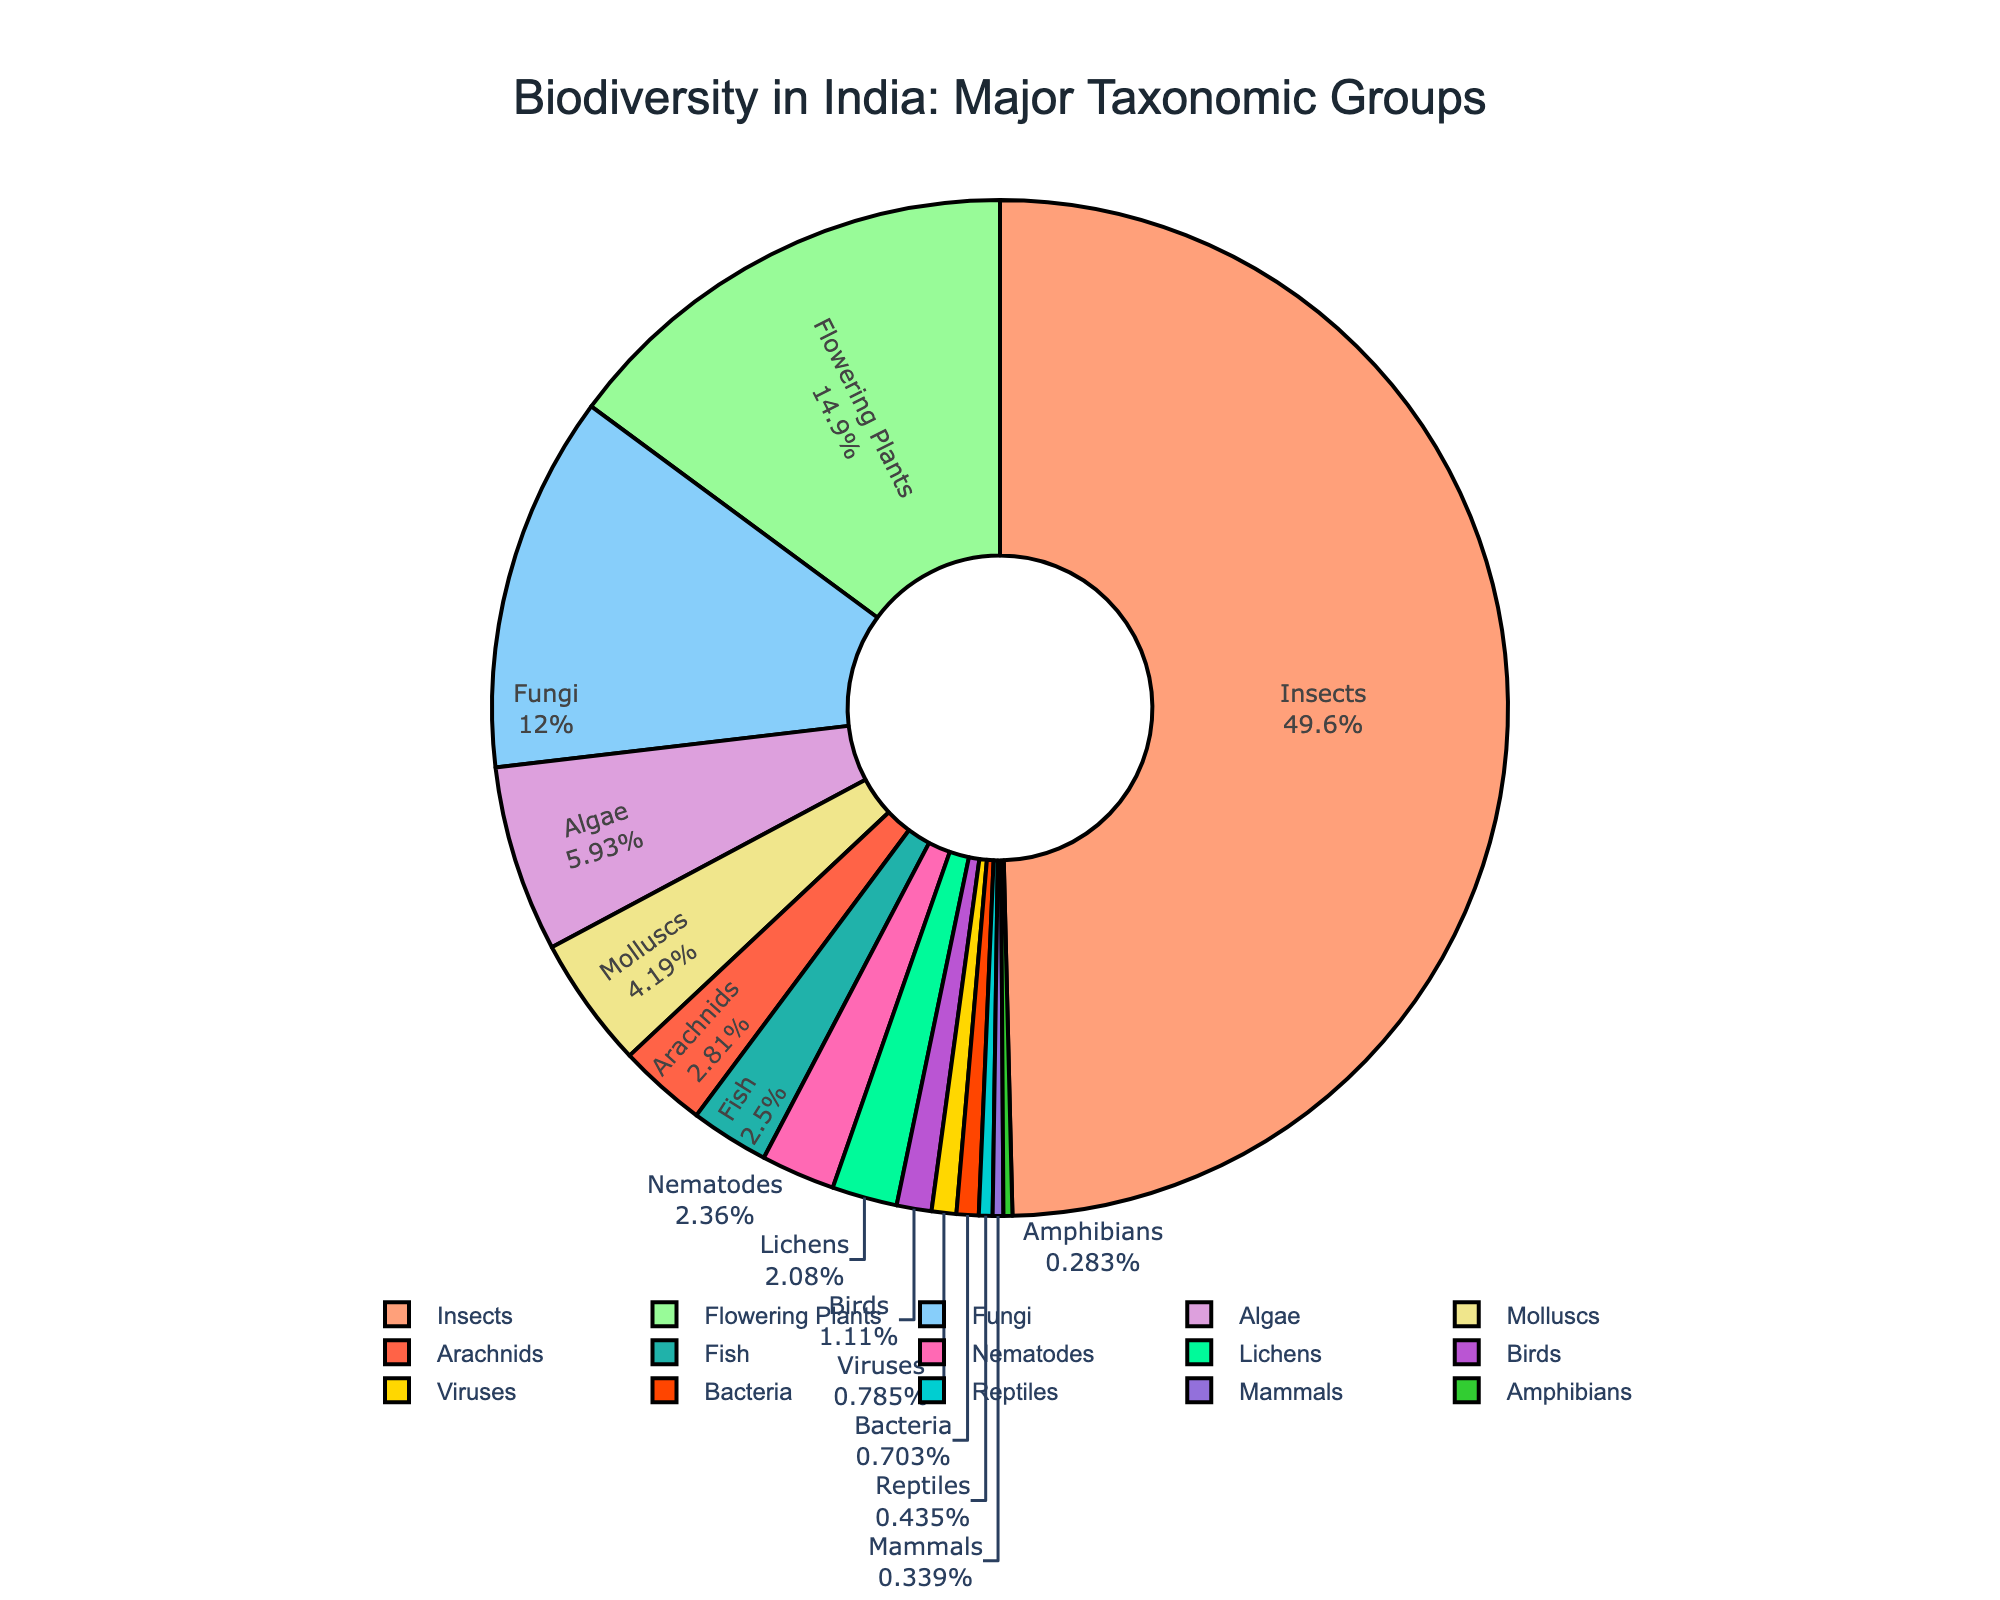Which taxonomic group has the highest species count? Observing the pie chart, the largest slice is attributed to "Insects" indicating it has the highest count.
Answer: Insects Which taxonomic group has the lowest species count? The smallest slice in the pie chart corresponds to "Bacteria," implying it has the lowest count.
Answer: Bacteria What percentage of India's biodiversity is made up of Flowering Plants? By looking at the label inside the slice for Flowering Plants, we can see this percentage value directly shown.
Answer: 13.5% How does the species count of Birds compare to Mammals? Comparing the slices for Birds and Mammals, the slice for Birds is larger, indicating a higher count.
Answer: Birds have a higher count than Mammals How many more species of Insects are there compared to Fungi? Subtracting the count of Fungi from Insects (60,000 - 14,500) gives the difference.
Answer: 45,500 What is the total species count for Reptiles and Amphibians combined? Adding the species counts for Reptiles (526) and Amphibians (342) results in the total.
Answer: 868 Which taxonomic groups have a species count greater than 5000? Observing the slices, Insects, Flowering Plants, Fungi, Fish, and Molluscs have large slices indicating counts greater than 5000.
Answer: Insects, Flowering Plants, Fungi, Fish, Molluscs What percentage do Viruses contribute to the total biodiversity? By examining the label within the Viruses slice in the chart, we can extract the percentage.
Answer: 0.7% Are there more species of Arachnids or Lichens in India? Directly comparing the slices for Arachnids and Lichens, the slice for Arachnids is slightly larger.
Answer: Arachnids How do the species counts of Nematodes and Algae compare? From the pie chart, the Algae slice is larger than the Nematodes slice, indicating a higher species count.
Answer: Algae have a higher count than Nematodes 